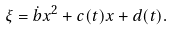<formula> <loc_0><loc_0><loc_500><loc_500>\xi = \dot { b } x ^ { 2 } + c ( t ) x + d ( t ) .</formula> 